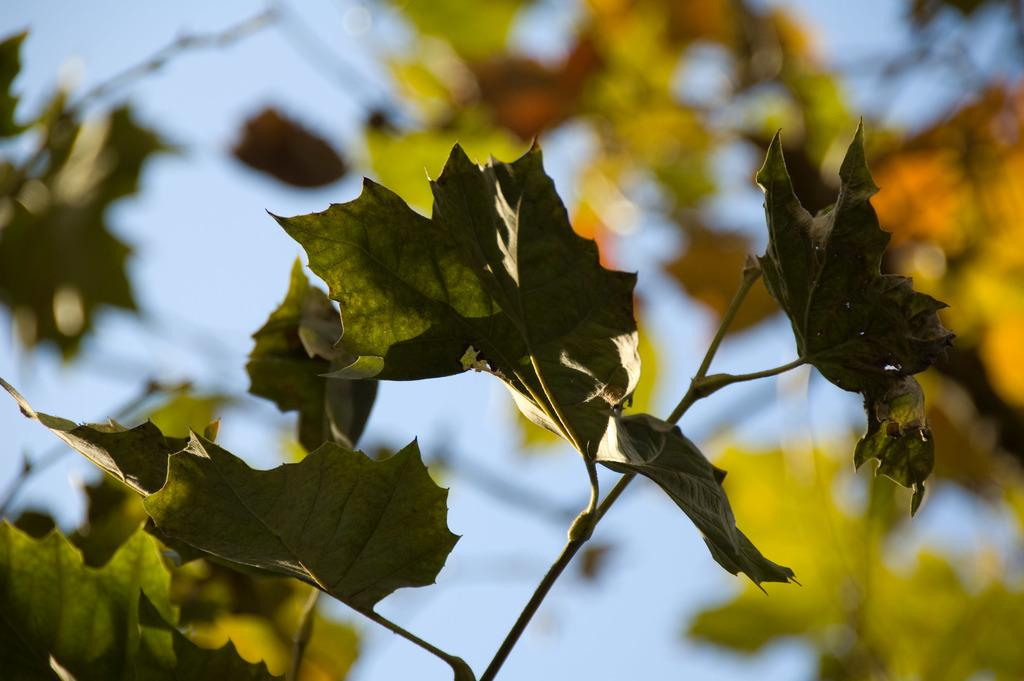What type of plant material can be seen in the image? There are leaves and stems in the image. What is visible behind the leaves in the image? The sky is visible behind the leaves in the image. What type of sound can be heard coming from the leaves in the image? There is no sound present in the image, as it is a still image of leaves and stems. 